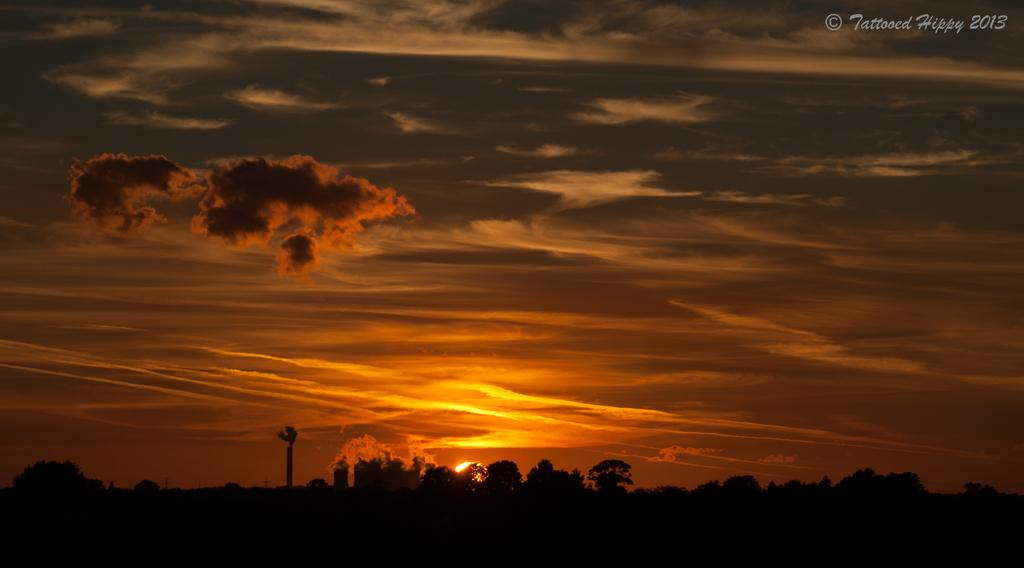What type of natural elements can be seen in the image? There are trees and clouds in the image. What celestial body is visible in the image? The sun is visible in the image. Where is the text located in the image? The text is in the top right hand corner of the image. What type of jelly can be seen on the trail in the image? There is no trail or jelly present in the image. What kind of crack is visible on the tree in the image? There is no crack visible on any tree in the image. 